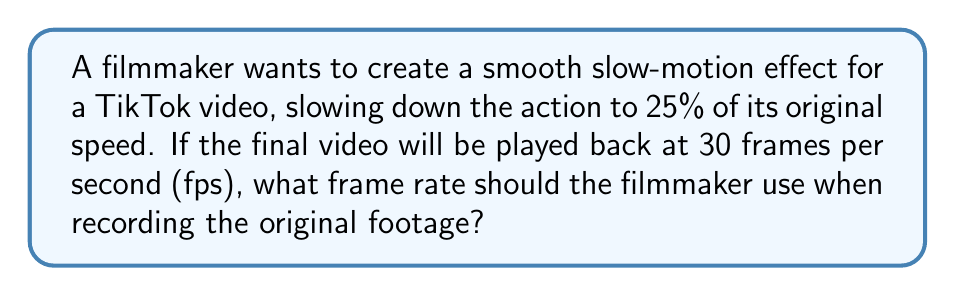Solve this math problem. Let's approach this step-by-step:

1) First, we need to understand the relationship between the original frame rate, the slow-motion effect, and the final playback rate.

2) Let $x$ be the original frame rate we're trying to find.

3) The slow-motion effect reduces the speed to 25% of the original, which means the footage will be played 4 times slower (because $\frac{1}{0.25} = 4$).

4) This means that for every second of playback time, we need 4 seconds worth of original footage.

5) We know the final video will be played at 30 fps. So, for each second of the final video, we need:

   $30 \text{ frames} \times 4 = 120 \text{ frames}$ of original footage

6) Therefore, the original footage needs to be shot at 120 fps.

7) We can verify this:
   - If we shoot at 120 fps and play it back at 30 fps, each second of playback will show $\frac{1}{4}$ second of real-time action.
   - This achieves the desired 25% speed (slow-motion) effect.

8) We can express this mathematically as:

   $$x \times 0.25 = 30$$
   $$x = \frac{30}{0.25} = 120$$
Answer: 120 fps 